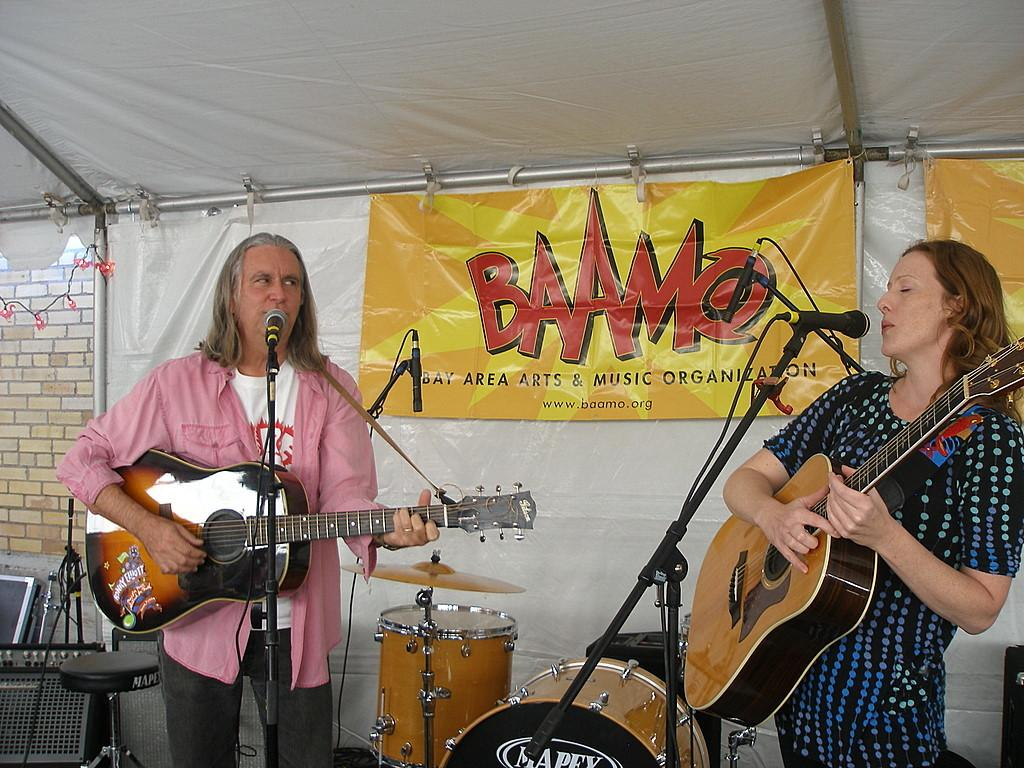What type of structure is visible in the image? There is a brick wall in the image. What else can be seen hanging in the image? There is a banner in the image. What are the two people in the image doing? The two people in the image are singing. What instruments are the people holding? The people are holding guitars in their hands. What musical instrument is located in the middle of the image? There are musical drums in the middle of the image. What type of scarf is being used to control the horses in the image? There are no horses or scarves present in the image. What is the taste of the ice cream being served in the image? There is no ice cream present in the image. 